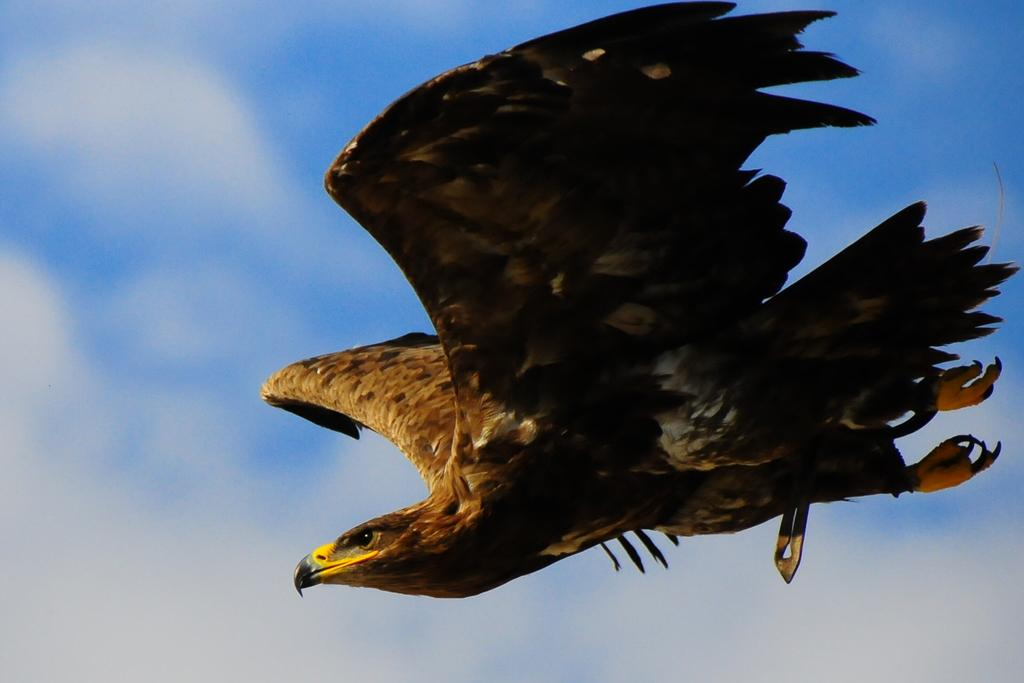What animal is featured in the image? There is an eagle in the image. What is the eagle doing in the image? The eagle is flying in the air. What can be seen in the background of the image? The sky is visible in the background of the image. What type of lift is being used by the committee in the image? There is no lift or committee present in the image; it features an eagle flying in the sky. How many times does the eagle shake hands with the other birds in the image? There are no other birds present in the image, and eagles do not have the ability to shake hands. 